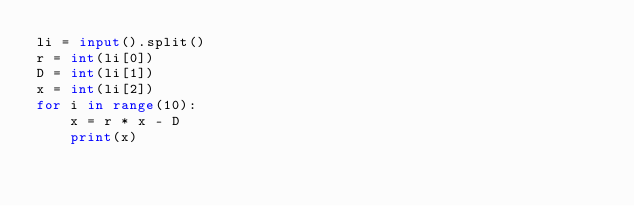<code> <loc_0><loc_0><loc_500><loc_500><_Python_>li = input().split()
r = int(li[0])
D = int(li[1])
x = int(li[2])
for i in range(10):
    x = r * x - D
    print(x)
</code> 